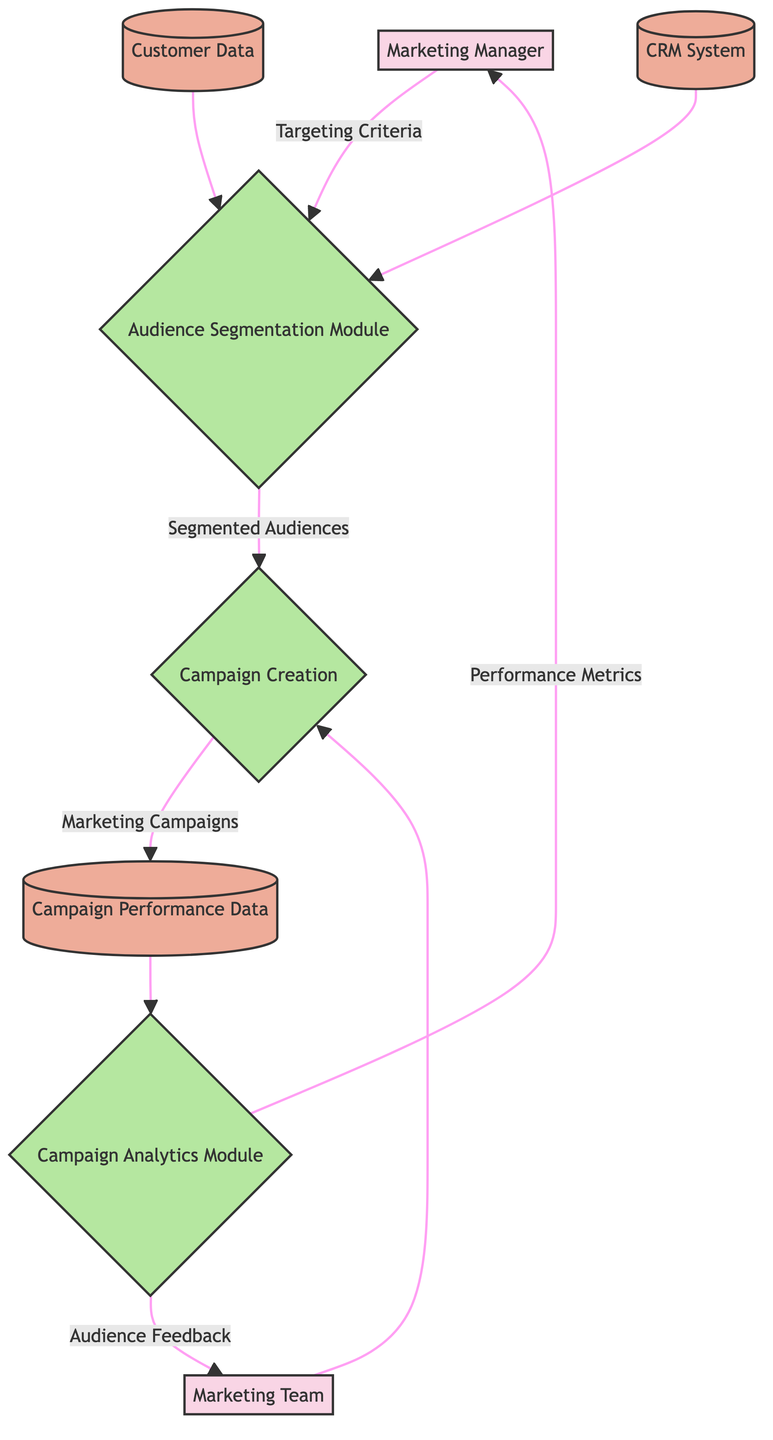What is the first process in the flow? The first process in the flow is the "Audience Segmentation Module", which is represented as a process node following inputs from the Marketing Manager, Customer Data, and CRM System.
Answer: Audience Segmentation Module How many external entities are present in the diagram? The diagram has two external entities, which are the Marketing Manager and the Marketing Team, each of which represents different stakeholders in the audience segmentation and targeting process.
Answer: 2 What data flow comes from the Audience Segmentation Module? The data flow that comes from the Audience Segmentation Module is "Segmented Audiences", which indicates the output generated after the segmentation is performed based on the input criteria.
Answer: Segmented Audiences Which data store receives the output of "Marketing Campaigns"? The output "Marketing Campaigns" flows into the "Campaign Performance Data" data store, where the results of the marketing campaigns are stored for future analysis.
Answer: Campaign Performance Data What are the two types of feedback coming from the Campaign Analytics Module? The two types of feedback coming from the Campaign Analytics Module are "Performance Metrics" directed to the Marketing Manager and "Audience Feedback" directed to the Marketing Team, providing insights on campaign effectiveness and audience response.
Answer: Performance Metrics, Audience Feedback Which external entity provides targeting criteria to the Audience Segmentation Module? The external entity that provides targeting criteria to the Audience Segmentation Module is the Marketing Manager, indicating that they are responsible for defining the parameters for audience segmentation.
Answer: Marketing Manager What role does the Customer Data play in the process? The Customer Data serves as a critical input for the Audience Segmentation Module, allowing the process to analyze relevant customer attributes for better targeting effectiveness.
Answer: Input for Audience Segmentation Module How many processes are depicted in the diagram? The diagram depicts four processes, which are the Audience Segmentation Module, Campaign Creation, and Campaign Analytics Module, each representing distinct functions within the audience segmentation and targeting workflow.
Answer: 4 What is the relationship between the Marketing Team and Campaign Creation? The relationship between the Marketing Team and Campaign Creation is that the Marketing Team provides input to the Campaign Creation process, indicating collaboration in developing marketing campaigns based on segmented audiences.
Answer: Input to Campaign Creation 